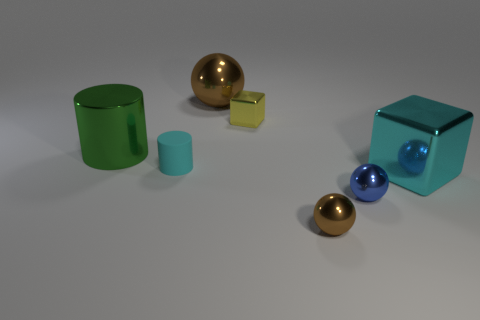Add 1 large metallic cubes. How many objects exist? 8 Subtract all blue balls. How many balls are left? 2 Add 2 large metal cubes. How many large metal cubes exist? 3 Subtract all yellow blocks. How many blocks are left? 1 Subtract 0 blue cylinders. How many objects are left? 7 Subtract all spheres. How many objects are left? 4 Subtract 1 cubes. How many cubes are left? 1 Subtract all green cylinders. Subtract all yellow spheres. How many cylinders are left? 1 Subtract all blue cubes. How many green cylinders are left? 1 Subtract all tiny red matte cylinders. Subtract all small things. How many objects are left? 3 